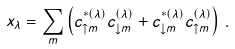Convert formula to latex. <formula><loc_0><loc_0><loc_500><loc_500>x _ { \lambda } = \sum _ { m } \left ( c _ { \uparrow m } ^ { \ast ( \lambda ) } c _ { \downarrow m } ^ { ( \lambda ) } + c _ { \downarrow m } ^ { \ast ( \lambda ) } c _ { \uparrow m } ^ { ( \lambda ) } \right ) \, .</formula> 